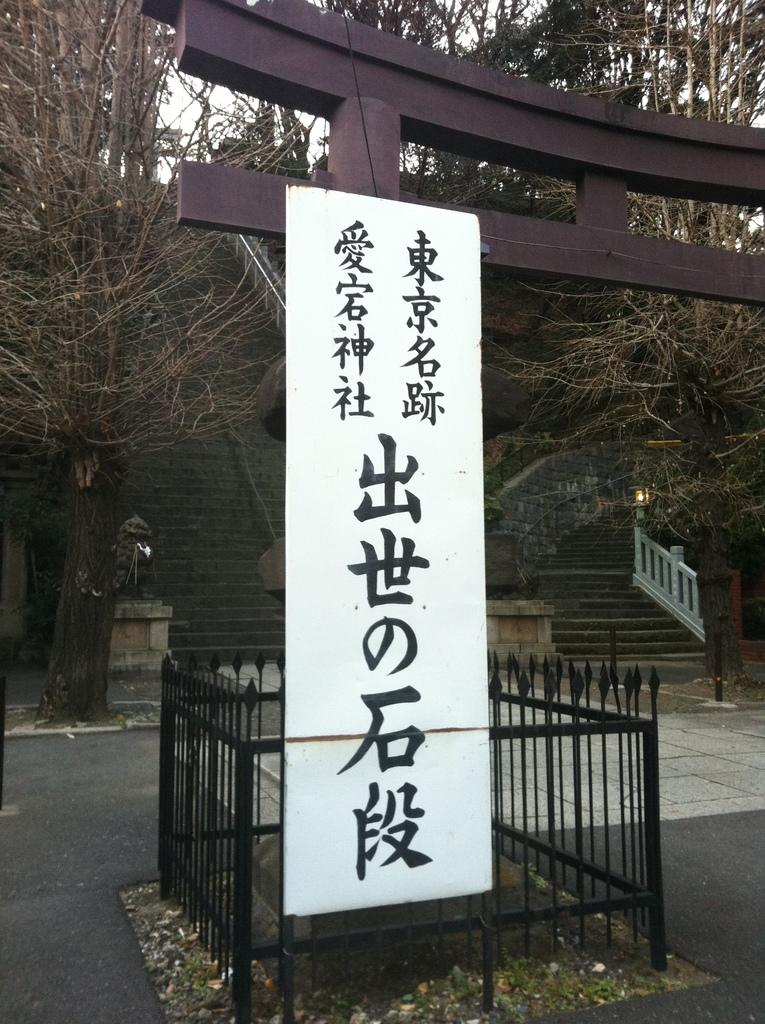What is attached to the pole in the image? There is a board with text in the image that is attached to a pole. How is the board attached to the pole and the fence? The board is attached to both the pole and the fence. What can be seen in the background of the image? There are stairs and trees visible in the background of the image. What type of leather is used to make the drink in the image? There is no drink or leather present in the image; it features a board with text attached to a pole and a fence. 